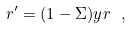<formula> <loc_0><loc_0><loc_500><loc_500>r ^ { \prime } = ( 1 - \Sigma ) y r \ ,</formula> 